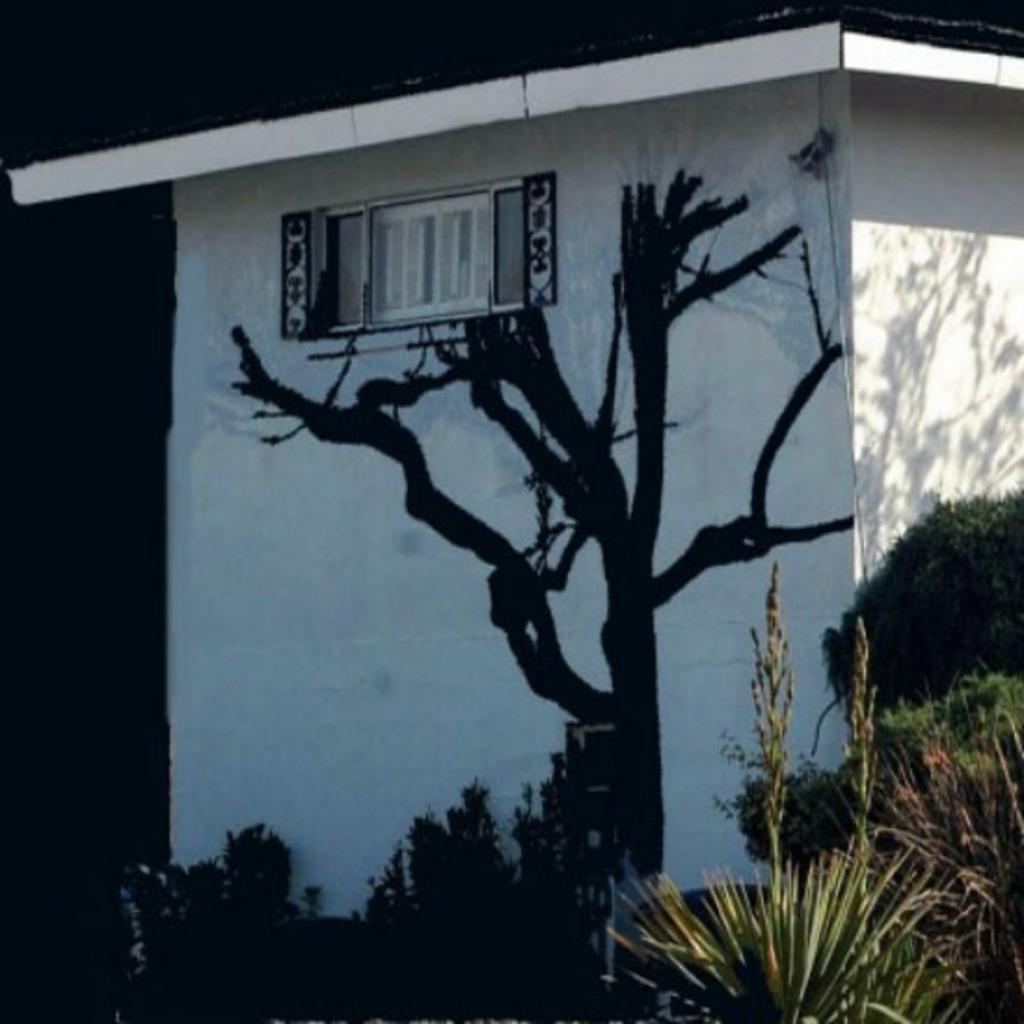What type of structure is present in the image? There is a building in the image. What type of vegetation is visible in the image? There are trees in the image. Can you describe any other visual elements in the image? There is a shadow visible in the image. What type of shoe can be seen in the image? There is no shoe present in the image. Is the image taken during the night? The information provided does not specify the time of day, so it cannot be determined if the image was taken during the night. 